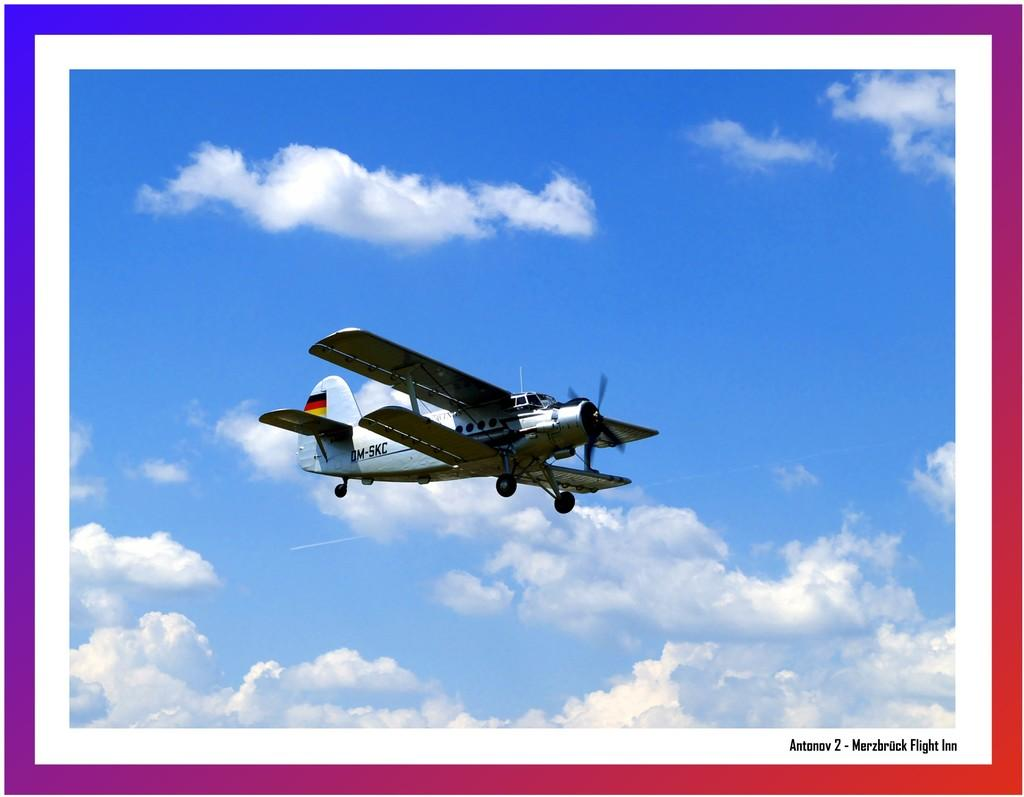What is the main subject of the image? The main subject of the image is an aircraft flying in the sky. Can you describe any additional features or elements in the image? There is a watermark at the bottom right side of the image. What type of nose can be seen on the aircraft in the image? There is no specific nose visible on the aircraft in the image, as it is a general representation of an aircraft. Is the image a copy of another image? The fact provided does not mention anything about the image being a copy, so we cannot determine if it is a copy or not based on the given information. 